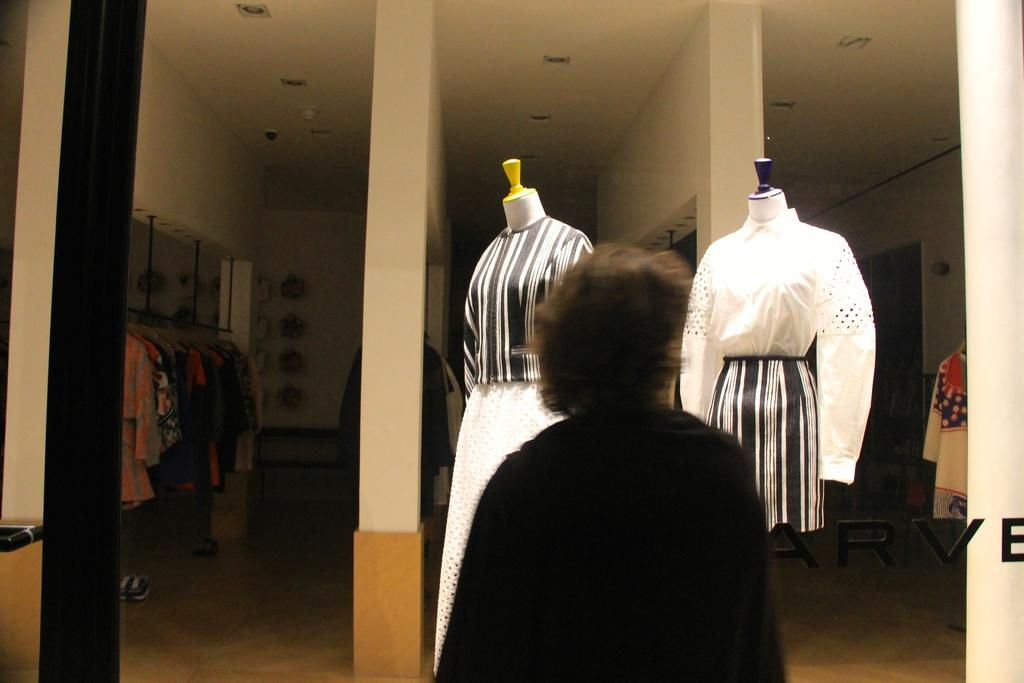What is the person in the image doing? The person is standing in the image. Where is the person standing? The person is standing on the floor. What can be seen in the background of the image? In the background of the image, there are clothes, mannequins, lights on the ceiling, walls, and other objects. How many square systems are present in the image? There is no mention of square systems in the image, so it is not possible to determine their presence or amount. 